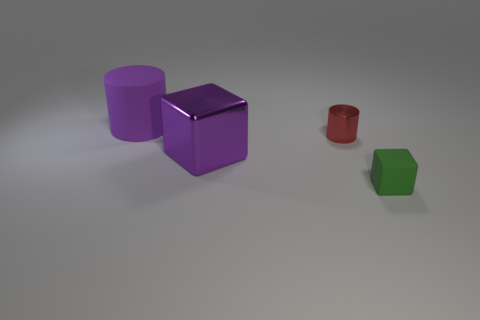Add 4 small green rubber cubes. How many objects exist? 8 Subtract 0 gray cylinders. How many objects are left? 4 Subtract all rubber cylinders. Subtract all purple metallic objects. How many objects are left? 2 Add 3 purple things. How many purple things are left? 5 Add 1 small purple metal objects. How many small purple metal objects exist? 1 